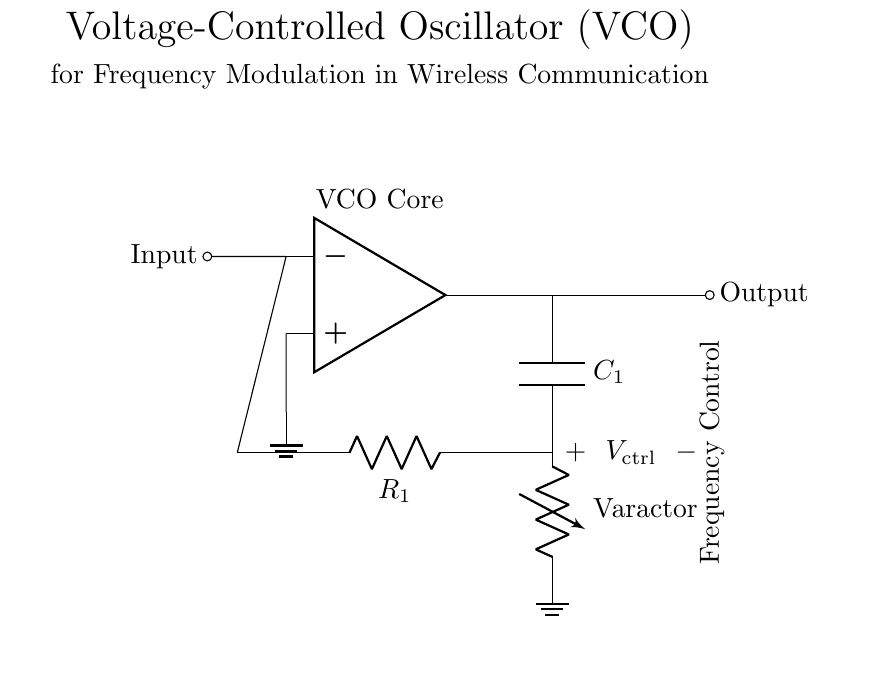What is the function of the op amp in this circuit? The op amp acts as the core of the voltage-controlled oscillator, amplifying the signal and controlling the frequency output based on the input voltage.
Answer: Voltage-controlled oscillator core What do C1 and R1 represent in the circuit? C1 is a capacitor, and R1 is a resistor; together, they form a feedback loop that stabilizes the oscillation frequency dependent on the control voltage.
Answer: Capacitor and resistor How is the frequency controlled in this oscillator? The frequency is controlled by the varying control voltage, which affects the capacitance of the varactor diode in the feedback loop, altering the oscillation frequency.
Answer: Control voltage What does the label "Varactor" indicate in the diagram? The label "Varactor" indicates a varactor diode, which is a type of diode used for voltage-controlled capacitance, essential for frequency modulation in this circuit.
Answer: Varactor diode Which component provides the output signal in the circuit? The output signal is provided by the op amp output, where the amplified oscillatory signal is taken to be transmitted or utilized in other parts of the circuit.
Answer: Op amp output What type of modulation does this VCO facilitate? This VCO facilitates frequency modulation, where the frequency of the output signal varies according to the amplitude of the input control voltage.
Answer: Frequency modulation 